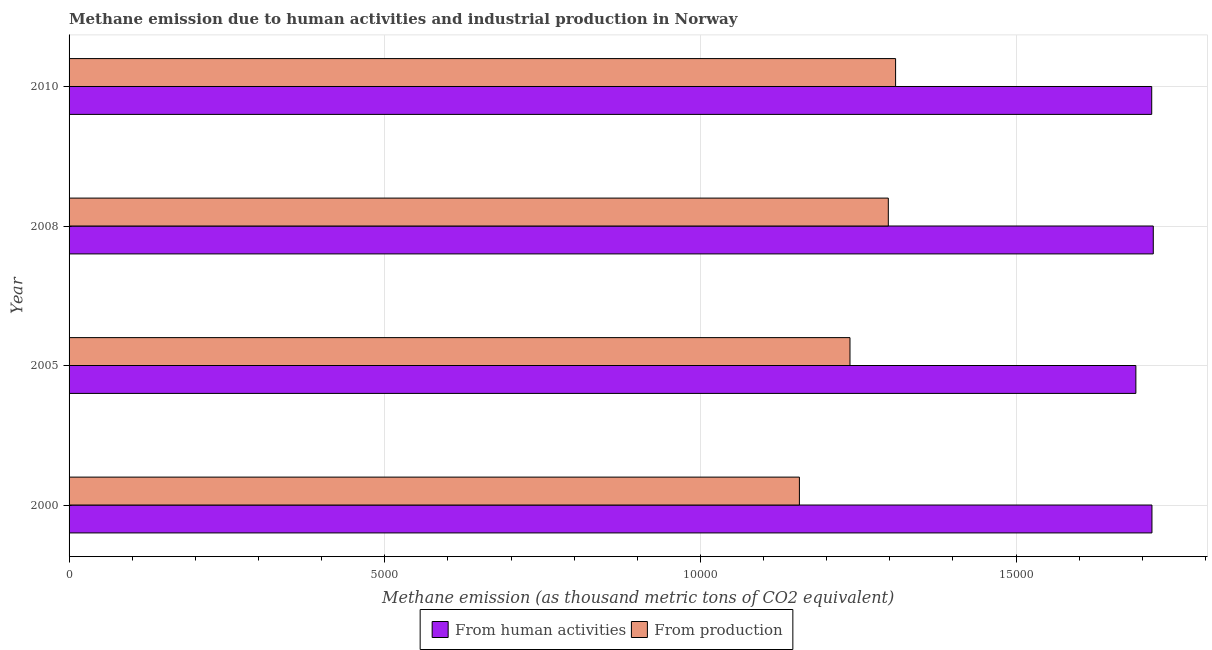How many groups of bars are there?
Provide a succinct answer. 4. How many bars are there on the 4th tick from the top?
Ensure brevity in your answer.  2. How many bars are there on the 3rd tick from the bottom?
Make the answer very short. 2. What is the amount of emissions generated from industries in 2010?
Your answer should be compact. 1.31e+04. Across all years, what is the maximum amount of emissions generated from industries?
Offer a very short reply. 1.31e+04. Across all years, what is the minimum amount of emissions generated from industries?
Make the answer very short. 1.16e+04. In which year was the amount of emissions from human activities minimum?
Ensure brevity in your answer.  2005. What is the total amount of emissions from human activities in the graph?
Offer a very short reply. 6.84e+04. What is the difference between the amount of emissions generated from industries in 2008 and that in 2010?
Offer a very short reply. -115.3. What is the difference between the amount of emissions generated from industries in 2000 and the amount of emissions from human activities in 2010?
Your response must be concise. -5580.2. What is the average amount of emissions from human activities per year?
Your answer should be very brief. 1.71e+04. In the year 2005, what is the difference between the amount of emissions generated from industries and amount of emissions from human activities?
Offer a very short reply. -4528.1. What is the ratio of the amount of emissions from human activities in 2005 to that in 2010?
Provide a short and direct response. 0.98. Is the amount of emissions generated from industries in 2005 less than that in 2008?
Your answer should be compact. Yes. Is the difference between the amount of emissions generated from industries in 2000 and 2005 greater than the difference between the amount of emissions from human activities in 2000 and 2005?
Offer a very short reply. No. What is the difference between the highest and the second highest amount of emissions generated from industries?
Provide a succinct answer. 115.3. What is the difference between the highest and the lowest amount of emissions generated from industries?
Make the answer very short. 1523.5. In how many years, is the amount of emissions from human activities greater than the average amount of emissions from human activities taken over all years?
Provide a short and direct response. 3. Is the sum of the amount of emissions generated from industries in 2000 and 2010 greater than the maximum amount of emissions from human activities across all years?
Your answer should be very brief. Yes. What does the 2nd bar from the top in 2005 represents?
Your answer should be very brief. From human activities. What does the 1st bar from the bottom in 2000 represents?
Provide a succinct answer. From human activities. How many bars are there?
Your answer should be compact. 8. Are all the bars in the graph horizontal?
Give a very brief answer. Yes. What is the difference between two consecutive major ticks on the X-axis?
Your response must be concise. 5000. Are the values on the major ticks of X-axis written in scientific E-notation?
Your answer should be compact. No. What is the title of the graph?
Offer a terse response. Methane emission due to human activities and industrial production in Norway. What is the label or title of the X-axis?
Give a very brief answer. Methane emission (as thousand metric tons of CO2 equivalent). What is the Methane emission (as thousand metric tons of CO2 equivalent) in From human activities in 2000?
Keep it short and to the point. 1.72e+04. What is the Methane emission (as thousand metric tons of CO2 equivalent) of From production in 2000?
Your answer should be compact. 1.16e+04. What is the Methane emission (as thousand metric tons of CO2 equivalent) of From human activities in 2005?
Your response must be concise. 1.69e+04. What is the Methane emission (as thousand metric tons of CO2 equivalent) in From production in 2005?
Give a very brief answer. 1.24e+04. What is the Methane emission (as thousand metric tons of CO2 equivalent) in From human activities in 2008?
Provide a succinct answer. 1.72e+04. What is the Methane emission (as thousand metric tons of CO2 equivalent) of From production in 2008?
Provide a succinct answer. 1.30e+04. What is the Methane emission (as thousand metric tons of CO2 equivalent) in From human activities in 2010?
Offer a terse response. 1.71e+04. What is the Methane emission (as thousand metric tons of CO2 equivalent) of From production in 2010?
Keep it short and to the point. 1.31e+04. Across all years, what is the maximum Methane emission (as thousand metric tons of CO2 equivalent) of From human activities?
Provide a succinct answer. 1.72e+04. Across all years, what is the maximum Methane emission (as thousand metric tons of CO2 equivalent) of From production?
Ensure brevity in your answer.  1.31e+04. Across all years, what is the minimum Methane emission (as thousand metric tons of CO2 equivalent) in From human activities?
Provide a succinct answer. 1.69e+04. Across all years, what is the minimum Methane emission (as thousand metric tons of CO2 equivalent) in From production?
Your response must be concise. 1.16e+04. What is the total Methane emission (as thousand metric tons of CO2 equivalent) of From human activities in the graph?
Offer a terse response. 6.84e+04. What is the total Methane emission (as thousand metric tons of CO2 equivalent) in From production in the graph?
Offer a very short reply. 5.00e+04. What is the difference between the Methane emission (as thousand metric tons of CO2 equivalent) in From human activities in 2000 and that in 2005?
Your response must be concise. 254.8. What is the difference between the Methane emission (as thousand metric tons of CO2 equivalent) of From production in 2000 and that in 2005?
Provide a short and direct response. -801. What is the difference between the Methane emission (as thousand metric tons of CO2 equivalent) in From human activities in 2000 and that in 2008?
Your answer should be very brief. -21. What is the difference between the Methane emission (as thousand metric tons of CO2 equivalent) of From production in 2000 and that in 2008?
Offer a terse response. -1408.2. What is the difference between the Methane emission (as thousand metric tons of CO2 equivalent) of From production in 2000 and that in 2010?
Make the answer very short. -1523.5. What is the difference between the Methane emission (as thousand metric tons of CO2 equivalent) in From human activities in 2005 and that in 2008?
Offer a terse response. -275.8. What is the difference between the Methane emission (as thousand metric tons of CO2 equivalent) in From production in 2005 and that in 2008?
Offer a terse response. -607.2. What is the difference between the Methane emission (as thousand metric tons of CO2 equivalent) of From human activities in 2005 and that in 2010?
Make the answer very short. -251.1. What is the difference between the Methane emission (as thousand metric tons of CO2 equivalent) of From production in 2005 and that in 2010?
Offer a very short reply. -722.5. What is the difference between the Methane emission (as thousand metric tons of CO2 equivalent) of From human activities in 2008 and that in 2010?
Ensure brevity in your answer.  24.7. What is the difference between the Methane emission (as thousand metric tons of CO2 equivalent) in From production in 2008 and that in 2010?
Offer a very short reply. -115.3. What is the difference between the Methane emission (as thousand metric tons of CO2 equivalent) in From human activities in 2000 and the Methane emission (as thousand metric tons of CO2 equivalent) in From production in 2005?
Offer a very short reply. 4782.9. What is the difference between the Methane emission (as thousand metric tons of CO2 equivalent) of From human activities in 2000 and the Methane emission (as thousand metric tons of CO2 equivalent) of From production in 2008?
Provide a succinct answer. 4175.7. What is the difference between the Methane emission (as thousand metric tons of CO2 equivalent) in From human activities in 2000 and the Methane emission (as thousand metric tons of CO2 equivalent) in From production in 2010?
Provide a short and direct response. 4060.4. What is the difference between the Methane emission (as thousand metric tons of CO2 equivalent) of From human activities in 2005 and the Methane emission (as thousand metric tons of CO2 equivalent) of From production in 2008?
Ensure brevity in your answer.  3920.9. What is the difference between the Methane emission (as thousand metric tons of CO2 equivalent) of From human activities in 2005 and the Methane emission (as thousand metric tons of CO2 equivalent) of From production in 2010?
Offer a terse response. 3805.6. What is the difference between the Methane emission (as thousand metric tons of CO2 equivalent) of From human activities in 2008 and the Methane emission (as thousand metric tons of CO2 equivalent) of From production in 2010?
Offer a terse response. 4081.4. What is the average Methane emission (as thousand metric tons of CO2 equivalent) in From human activities per year?
Offer a very short reply. 1.71e+04. What is the average Methane emission (as thousand metric tons of CO2 equivalent) in From production per year?
Provide a succinct answer. 1.25e+04. In the year 2000, what is the difference between the Methane emission (as thousand metric tons of CO2 equivalent) of From human activities and Methane emission (as thousand metric tons of CO2 equivalent) of From production?
Your answer should be very brief. 5583.9. In the year 2005, what is the difference between the Methane emission (as thousand metric tons of CO2 equivalent) of From human activities and Methane emission (as thousand metric tons of CO2 equivalent) of From production?
Your answer should be compact. 4528.1. In the year 2008, what is the difference between the Methane emission (as thousand metric tons of CO2 equivalent) in From human activities and Methane emission (as thousand metric tons of CO2 equivalent) in From production?
Your answer should be compact. 4196.7. In the year 2010, what is the difference between the Methane emission (as thousand metric tons of CO2 equivalent) of From human activities and Methane emission (as thousand metric tons of CO2 equivalent) of From production?
Give a very brief answer. 4056.7. What is the ratio of the Methane emission (as thousand metric tons of CO2 equivalent) in From human activities in 2000 to that in 2005?
Provide a succinct answer. 1.02. What is the ratio of the Methane emission (as thousand metric tons of CO2 equivalent) in From production in 2000 to that in 2005?
Give a very brief answer. 0.94. What is the ratio of the Methane emission (as thousand metric tons of CO2 equivalent) of From human activities in 2000 to that in 2008?
Ensure brevity in your answer.  1. What is the ratio of the Methane emission (as thousand metric tons of CO2 equivalent) of From production in 2000 to that in 2008?
Make the answer very short. 0.89. What is the ratio of the Methane emission (as thousand metric tons of CO2 equivalent) in From human activities in 2000 to that in 2010?
Offer a terse response. 1. What is the ratio of the Methane emission (as thousand metric tons of CO2 equivalent) of From production in 2000 to that in 2010?
Keep it short and to the point. 0.88. What is the ratio of the Methane emission (as thousand metric tons of CO2 equivalent) of From human activities in 2005 to that in 2008?
Provide a succinct answer. 0.98. What is the ratio of the Methane emission (as thousand metric tons of CO2 equivalent) of From production in 2005 to that in 2008?
Your answer should be very brief. 0.95. What is the ratio of the Methane emission (as thousand metric tons of CO2 equivalent) of From human activities in 2005 to that in 2010?
Provide a succinct answer. 0.99. What is the ratio of the Methane emission (as thousand metric tons of CO2 equivalent) of From production in 2005 to that in 2010?
Your answer should be compact. 0.94. What is the ratio of the Methane emission (as thousand metric tons of CO2 equivalent) of From human activities in 2008 to that in 2010?
Keep it short and to the point. 1. What is the difference between the highest and the second highest Methane emission (as thousand metric tons of CO2 equivalent) of From human activities?
Ensure brevity in your answer.  21. What is the difference between the highest and the second highest Methane emission (as thousand metric tons of CO2 equivalent) of From production?
Provide a short and direct response. 115.3. What is the difference between the highest and the lowest Methane emission (as thousand metric tons of CO2 equivalent) of From human activities?
Your answer should be very brief. 275.8. What is the difference between the highest and the lowest Methane emission (as thousand metric tons of CO2 equivalent) in From production?
Your answer should be compact. 1523.5. 